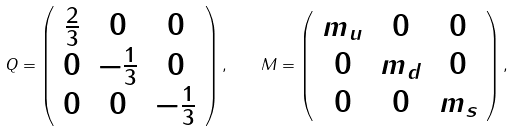Convert formula to latex. <formula><loc_0><loc_0><loc_500><loc_500>Q = \left ( \begin{array} { c c c } \frac { 2 } { 3 } & 0 & 0 \\ 0 & - \frac { 1 } { 3 } & 0 \\ 0 & 0 & - \frac { 1 } { 3 } \end{array} \right ) , \quad M = \left ( \begin{array} { c c c } m _ { u } & 0 & 0 \\ 0 & m _ { d } & 0 \\ 0 & 0 & m _ { s } \end{array} \right ) ,</formula> 